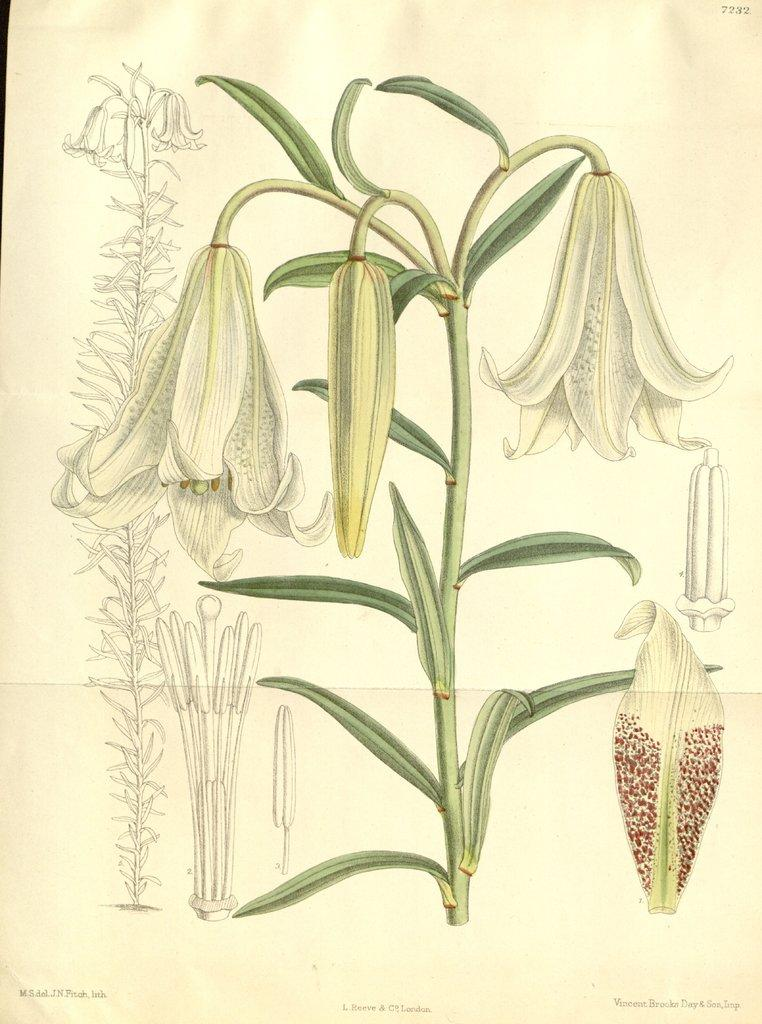What can be seen on the wall in the image? There is a poster in the image. What is growing on the plant in the image? There are flowers and buds on the plant in the image. What other plant-related information is on the poster? There are other plant-related diagrams on the poster in the image. How far away is the rain from the plant in the image? There is no rain present in the image, so it cannot be determined how far away it is from the plant. What type of jewel can be seen on the poster in the image? There are no jewels present on the poster or in the image. 